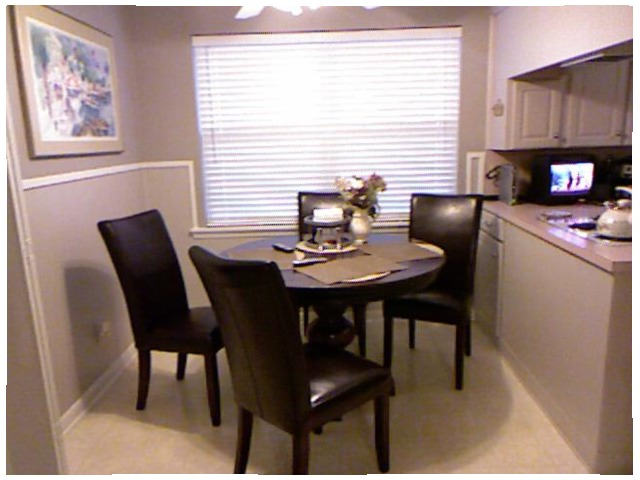<image>
Is there a table in front of the chair? Yes. The table is positioned in front of the chair, appearing closer to the camera viewpoint. 